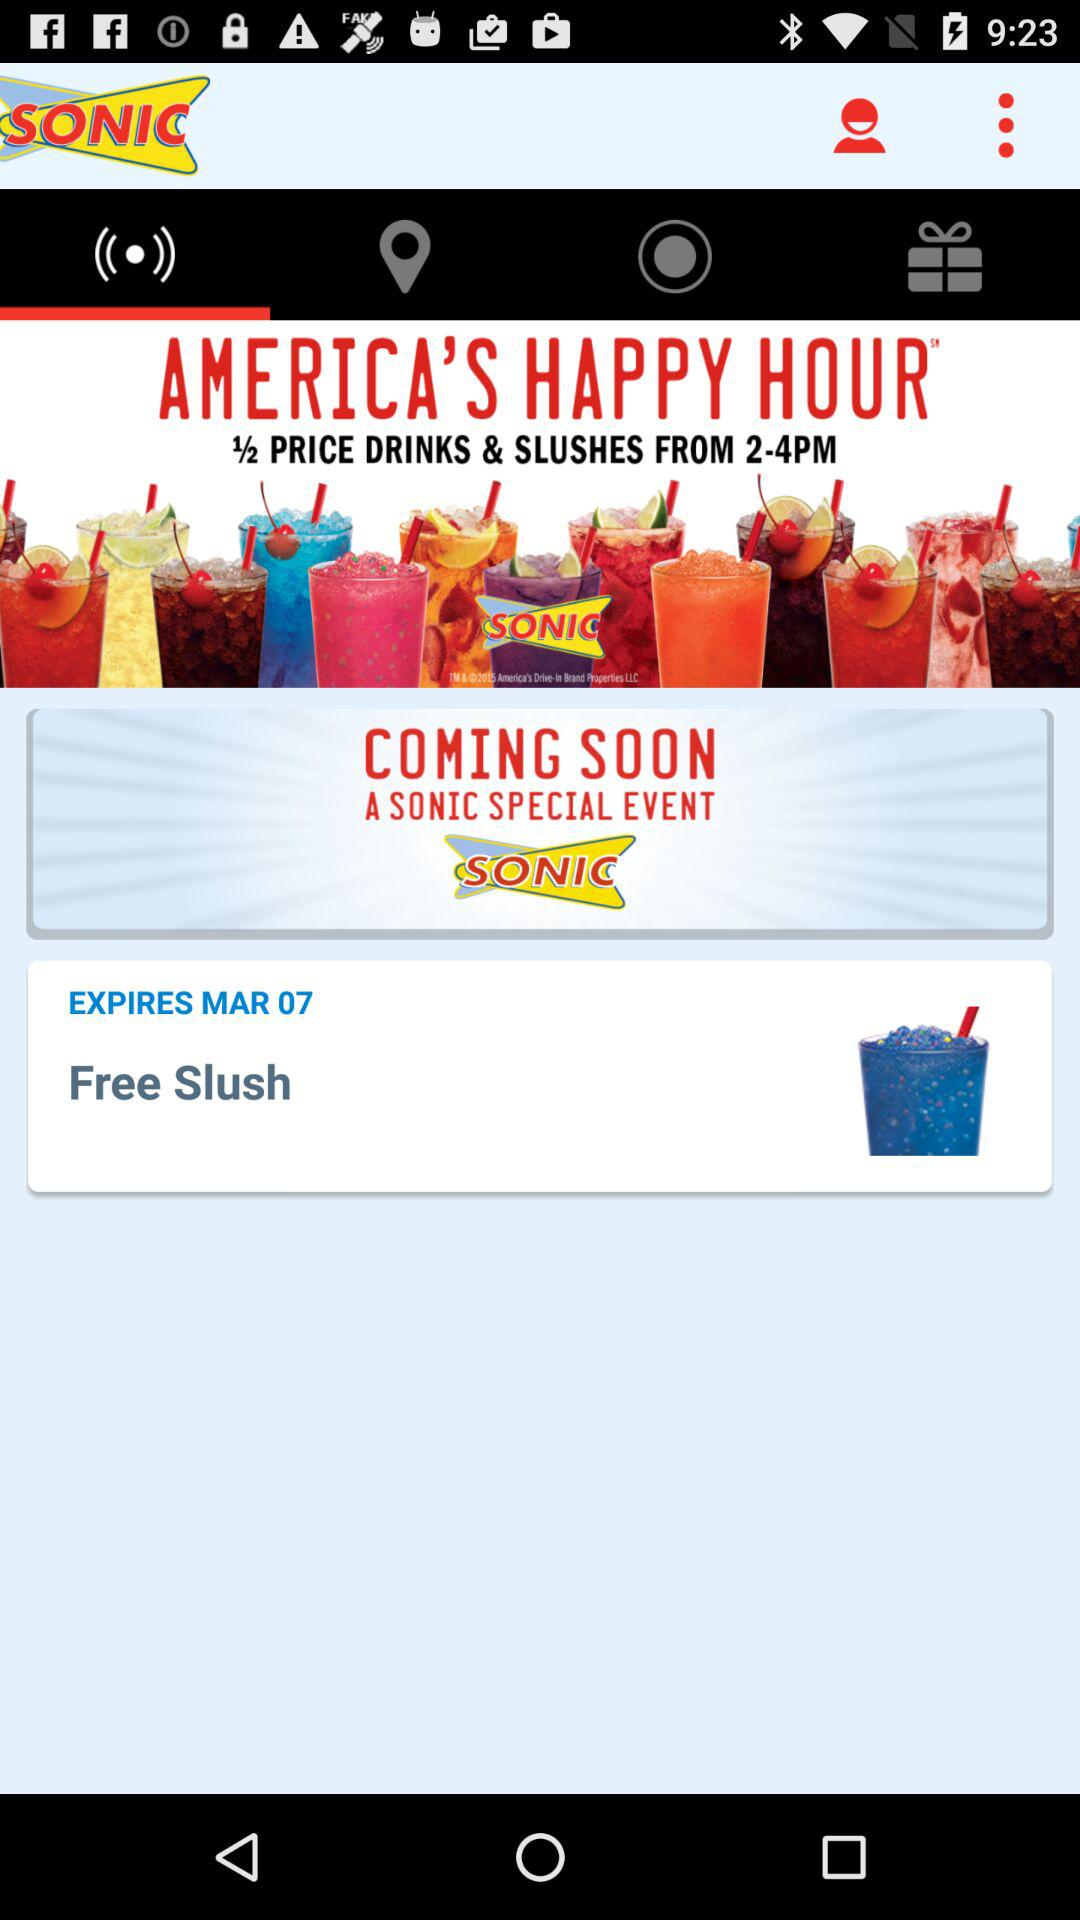What is the expiration date of free slushes? The expiration date of free slushes is March 7. 